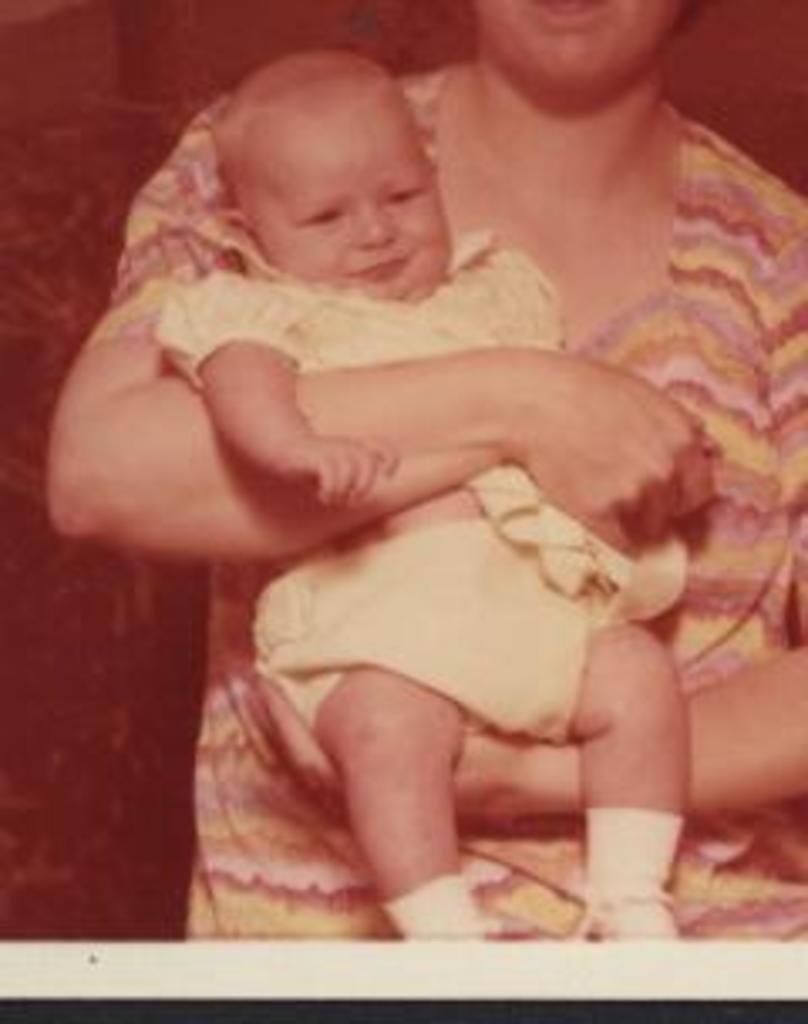Who is the main subject in the image? There is a woman in the image. What is the woman doing in the image? The woman is carrying a baby. Where is the pail located in the image? There is no pail present in the image. How many horses can be seen in the image? There are no horses present in the image. 